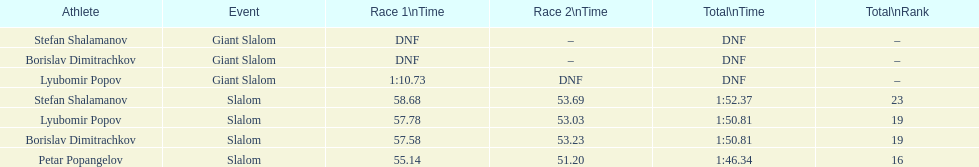Who was the other sportsman that shared a ranking with lyubomir popov? Borislav Dimitrachkov. 